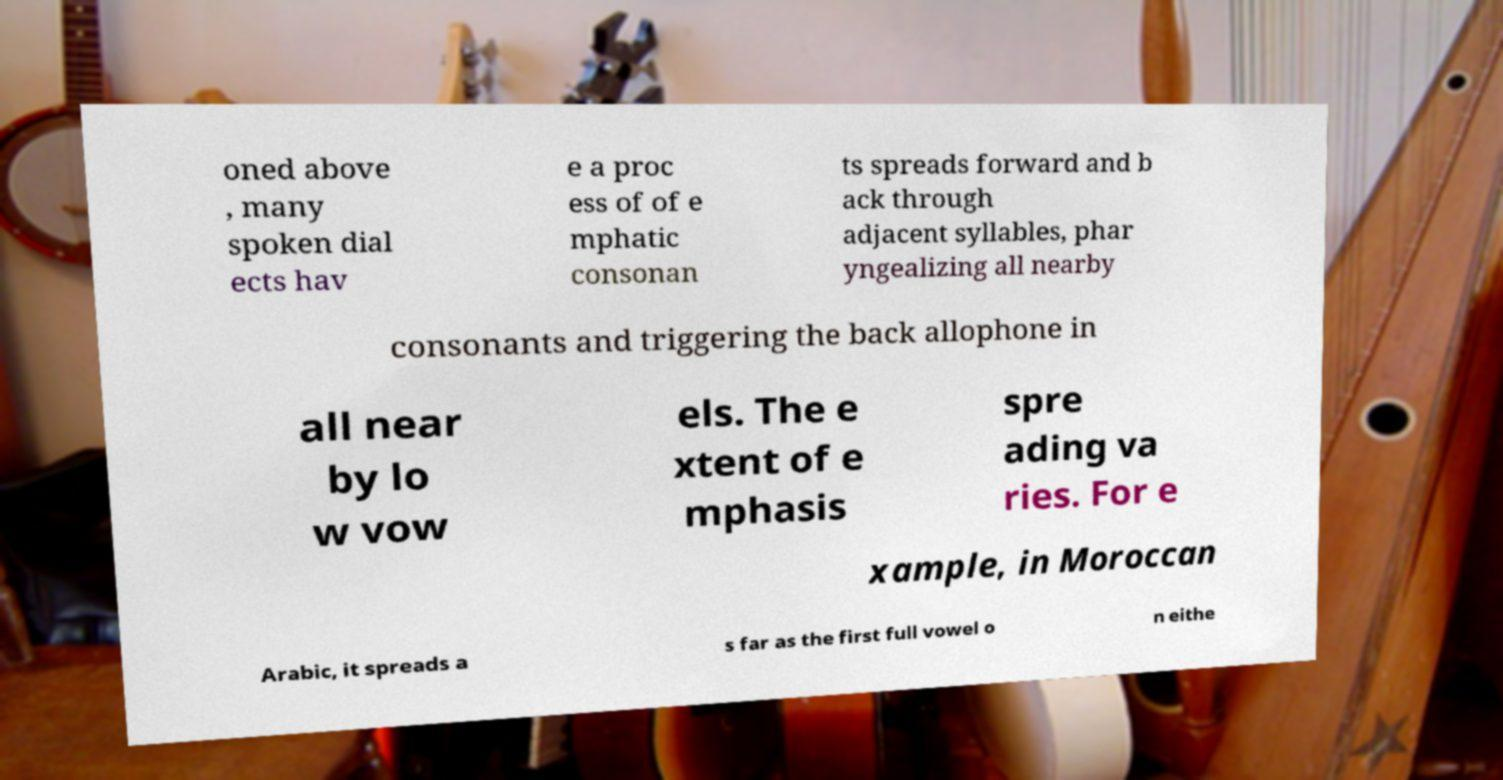What messages or text are displayed in this image? I need them in a readable, typed format. oned above , many spoken dial ects hav e a proc ess of of e mphatic consonan ts spreads forward and b ack through adjacent syllables, phar yngealizing all nearby consonants and triggering the back allophone in all near by lo w vow els. The e xtent of e mphasis spre ading va ries. For e xample, in Moroccan Arabic, it spreads a s far as the first full vowel o n eithe 